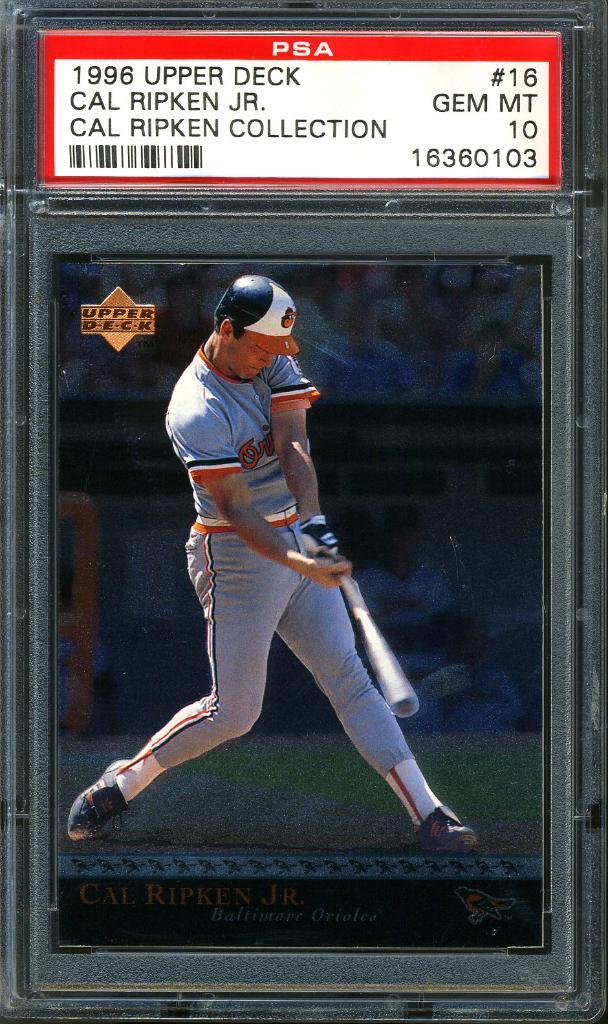<image>
Relay a brief, clear account of the picture shown. a baseball card for cal ripken jr in a glass case 